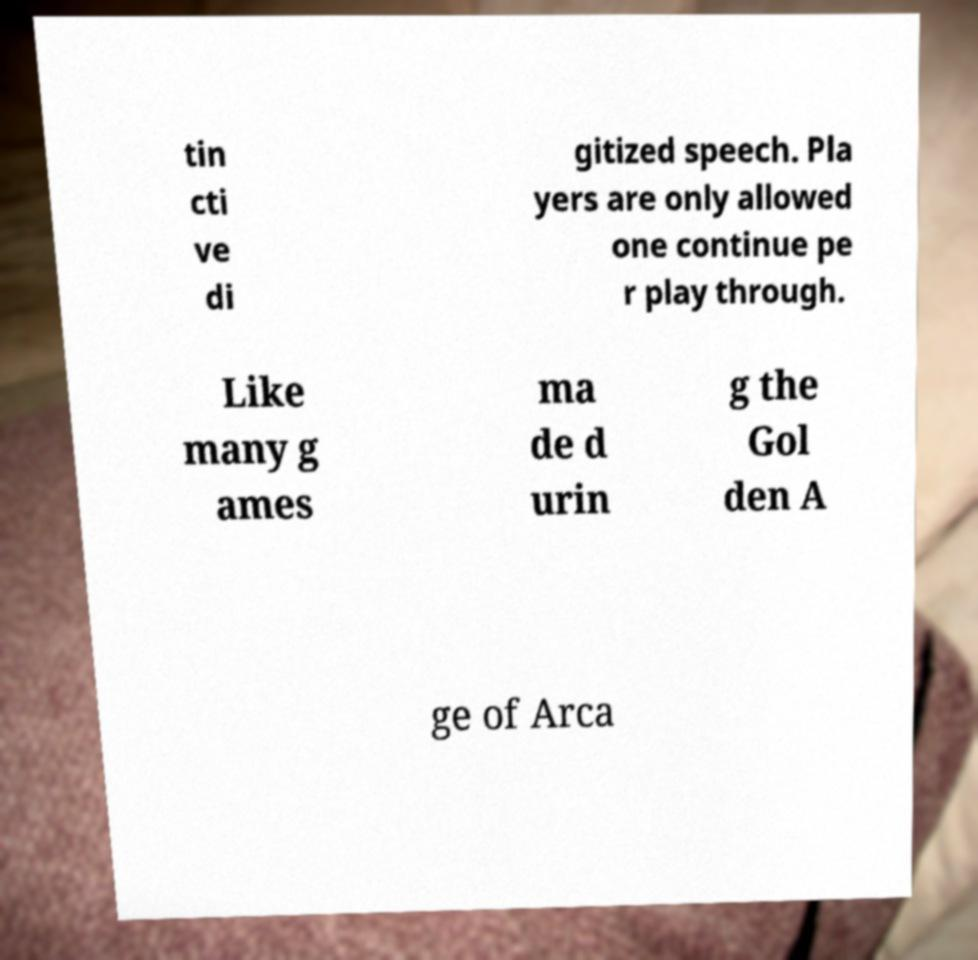Please identify and transcribe the text found in this image. tin cti ve di gitized speech. Pla yers are only allowed one continue pe r play through. Like many g ames ma de d urin g the Gol den A ge of Arca 